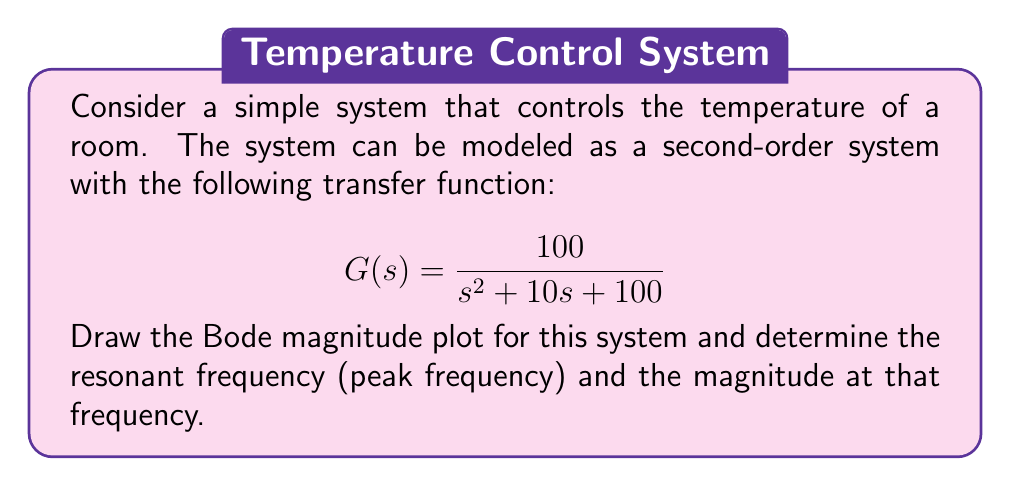Could you help me with this problem? For a person unfamiliar with control theory, let's break this down step by step:

1) A Bode plot is a graph that shows how a system responds to different frequencies. The magnitude plot shows how much the system amplifies or attenuates the input at each frequency.

2) For a second-order system with the general form:

   $$ G(s) = \frac{\omega_n^2}{s^2 + 2\zeta\omega_n s + \omega_n^2} $$

   Where $\omega_n$ is the natural frequency and $\zeta$ is the damping ratio.

3) Comparing our system to the general form, we can see that:
   $\omega_n^2 = 100$, so $\omega_n = 10$ rad/s
   $2\zeta\omega_n = 10$, so $\zeta = 0.5$

4) The resonant frequency (peak frequency) for a second-order system is given by:

   $$ \omega_r = \omega_n\sqrt{1-2\zeta^2} $$

5) Substituting our values:

   $$ \omega_r = 10\sqrt{1-2(0.5)^2} = 10\sqrt{0.5} \approx 7.07 \text{ rad/s} $$

6) The magnitude at the resonant frequency is given by:

   $$ |G(j\omega_r)| = \frac{1}{2\zeta\sqrt{1-\zeta^2}} $$

7) Substituting our $\zeta$ value:

   $$ |G(j\omega_r)| = \frac{1}{2(0.5)\sqrt{1-(0.5)^2}} = \frac{1}{\sqrt{0.75}} \approx 1.155 $$

8) To draw the Bode magnitude plot, we would typically use a logarithmic scale for both frequency and magnitude. The plot would show a flat response at low frequencies, a peak at the resonant frequency, and then a decline of -40 dB/decade at high frequencies.
Answer: The resonant frequency is approximately 7.07 rad/s, and the magnitude at this frequency is approximately 1.155 (or 1.25 dB). 